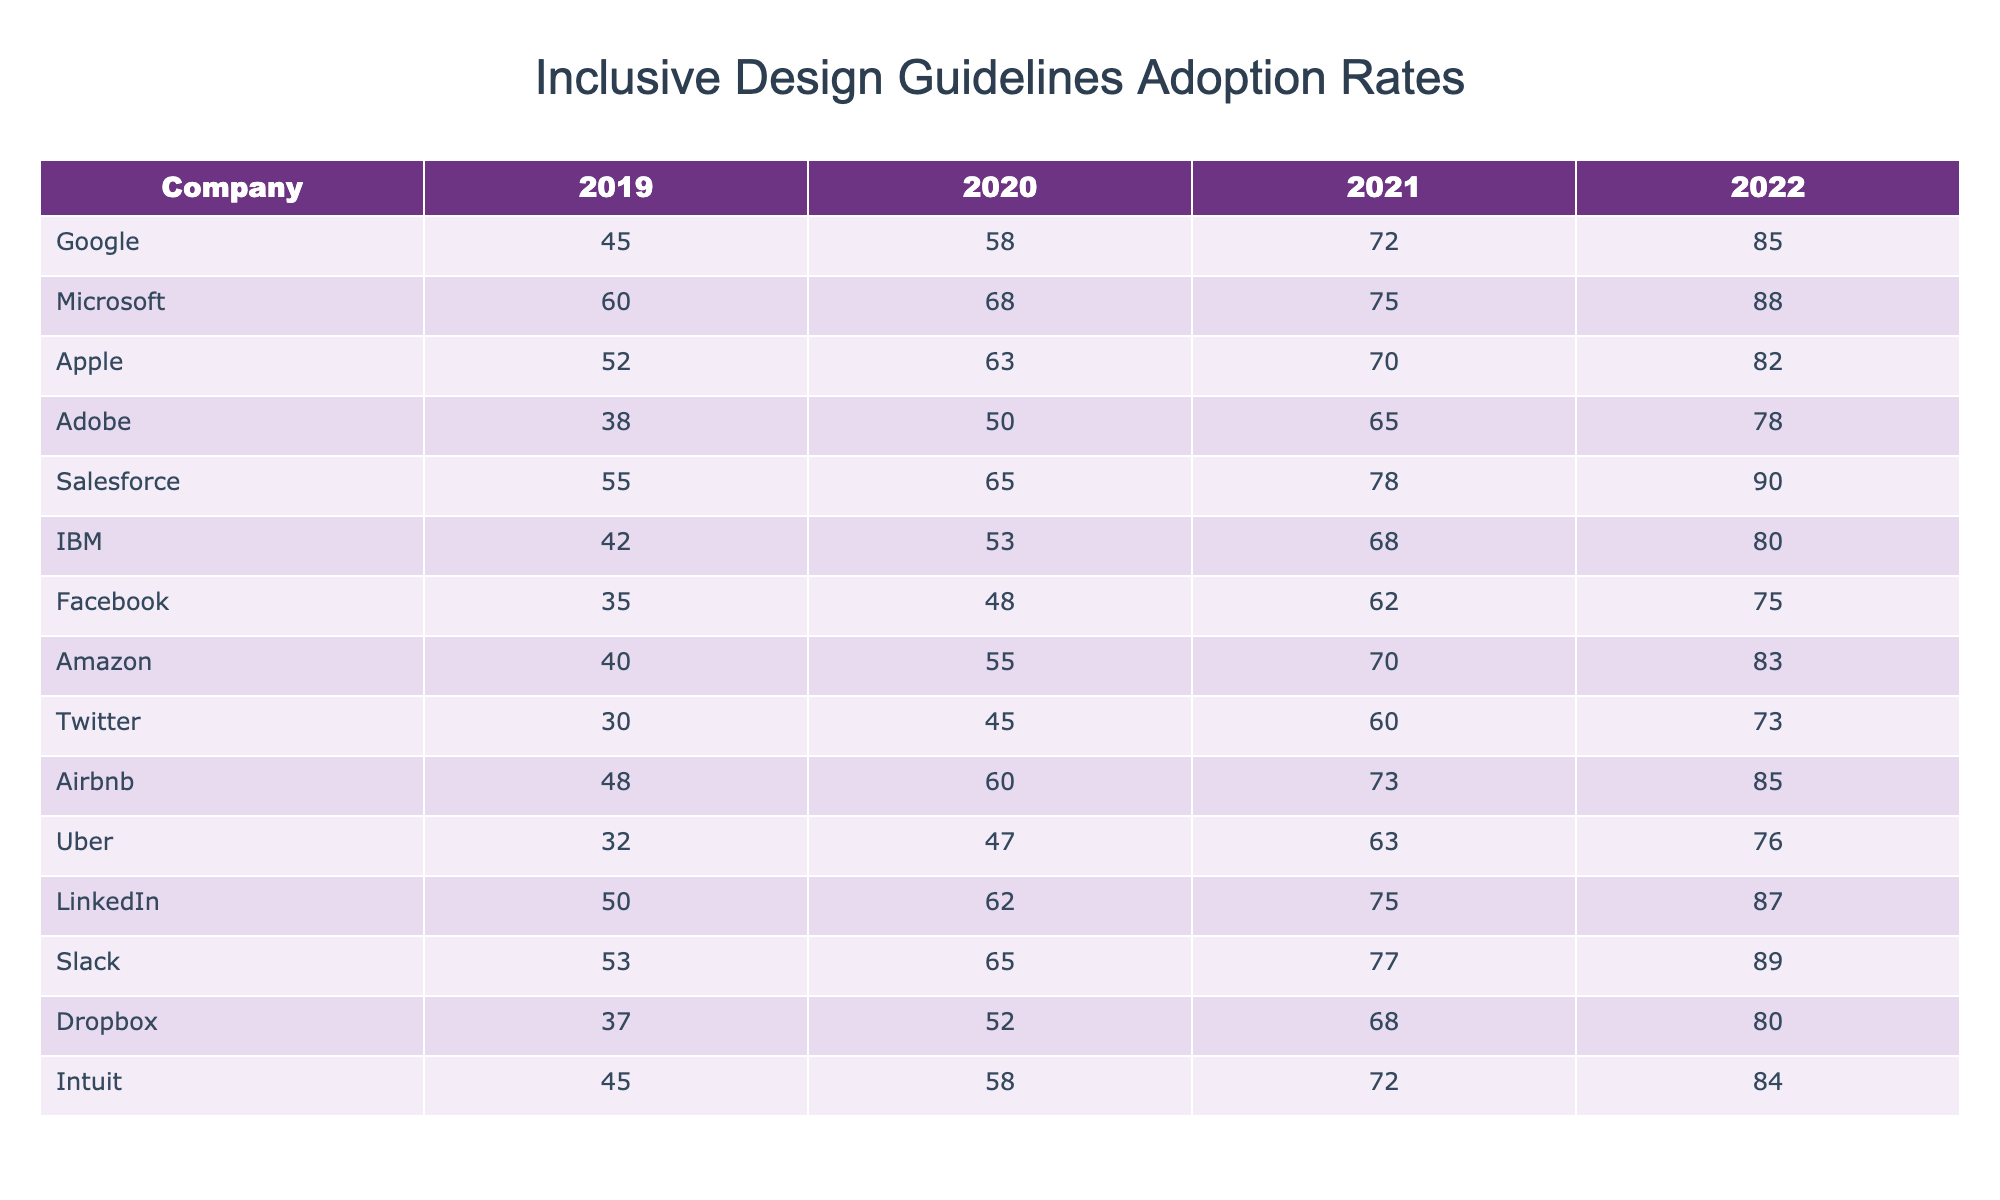What was the highest adoption rate in 2022? Looking at the 2022 column, the adoption rates are as follows: Google (85), Microsoft (88), Apple (82), Adobe (78), Salesforce (90), IBM (80), Facebook (75), Amazon (83), Twitter (73), Airbnb (85), Uber (76), LinkedIn (87), Slack (89), Dropbox (80), and Intuit (84). The highest value is 90 for Salesforce.
Answer: 90 Which company had the lowest adoption rate in 2019? In the 2019 column, the rates are: Google (45), Microsoft (60), Apple (52), Adobe (38), Salesforce (55), IBM (42), Facebook (35), Amazon (40), Twitter (30), Airbnb (48), Uber (32), LinkedIn (50), Slack (53), Dropbox (37), and Intuit (45). The lowest value is 30 for Twitter.
Answer: 30 What was the adoption rate increase for Adobe from 2019 to 2022? Adobe's adoption rates are: 2019 (38), 2020 (50), 2021 (65), and 2022 (78). The increase from 38 to 78 is calculated as 78 - 38 = 40.
Answer: 40 Did Salesforce consistently increase its adoption rate every year? Looking at the Salesforce data: 2019 (55), 2020 (65), 2021 (78), 2022 (90). Each subsequent year shows an increase: 55 to 65, 65 to 78, and 78 to 90, confirming consistent growth.
Answer: Yes What is the average adoption rate for all companies in 2021? We sum the adoption rates for 2021, which are: 72 (Google) + 75 (Microsoft) + 70 (Apple) + 65 (Adobe) + 78 (Salesforce) + 68 (IBM) + 62 (Facebook) + 70 (Amazon) + 60 (Twitter) + 73 (Airbnb) + 63 (Uber) + 75 (LinkedIn) + 77 (Slack) + 68 (Dropbox) + 72 (Intuit) = 1,029. There are 14 companies, so the average is 1,029 / 14 ≈ 73.50.
Answer: 73.50 Which company gained the most in terms of adoption rate from 2019 to 2022? We calculate the increase for each company from 2019 to 2022: Salesforce: 90 - 55 = 35, LinkedIn: 87 - 50 = 37, Microsoft: 88 - 60 = 28, etc. Upon comparing all increases, LinkedIn has the highest increase of 37.
Answer: LinkedIn Is it true that all companies improved their adoption rates from 2019 to 2022? We check each company’s values in 2019 and their corresponding values in 2022. All companies showed an increase, confirming that no company decreased its rates.
Answer: Yes What is the difference in adoption rates between the highest and lowest companies in 2022? The highest in 2022 is Salesforce (90) and the lowest is Facebook (75). The difference between these two values is 90 - 75 = 15.
Answer: 15 What was the median adoption rate for the companies in 2020? To find the median, we first list the adoption rates for 2020 in ascending order: 45 (Twitter), 50 (Adobe), 52 (Dropbox), 58 (Google), 60 (Airbnb), 62 (LinkedIn), 63 (Apple), 65 (Slack), 68 (Microsoft), 70 (Amazon), 75 (Salesforce), 78 (IBM), 80 (Facebook) = 62.5 as there is an even number of data points (14). Average of the two middle numbers (62 and 63) gives median.
Answer: 62.5 